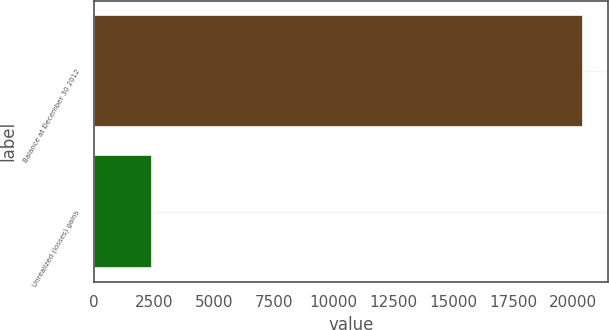Convert chart. <chart><loc_0><loc_0><loc_500><loc_500><bar_chart><fcel>Balance at December 30 2012<fcel>Unrealized (losses) gains<nl><fcel>20431<fcel>2409<nl></chart> 